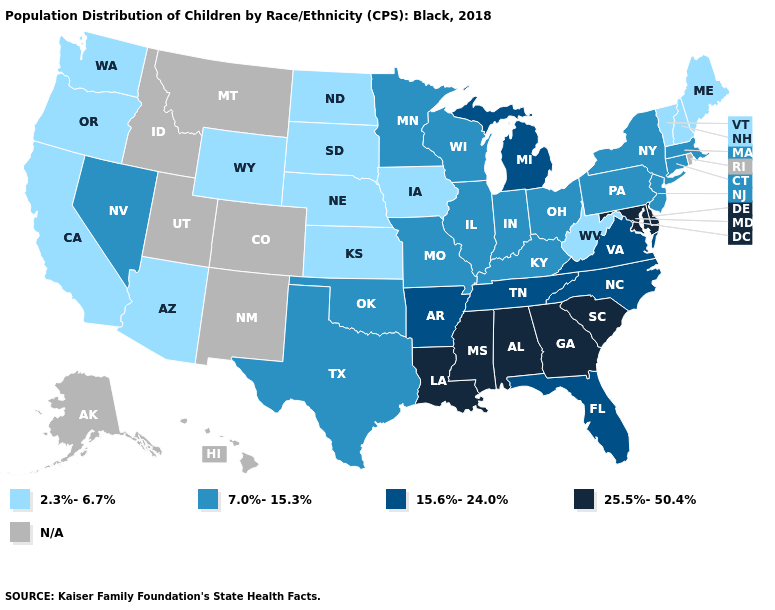Name the states that have a value in the range 25.5%-50.4%?
Concise answer only. Alabama, Delaware, Georgia, Louisiana, Maryland, Mississippi, South Carolina. What is the value of Ohio?
Write a very short answer. 7.0%-15.3%. How many symbols are there in the legend?
Short answer required. 5. Name the states that have a value in the range 7.0%-15.3%?
Keep it brief. Connecticut, Illinois, Indiana, Kentucky, Massachusetts, Minnesota, Missouri, Nevada, New Jersey, New York, Ohio, Oklahoma, Pennsylvania, Texas, Wisconsin. What is the lowest value in the West?
Keep it brief. 2.3%-6.7%. Does Delaware have the lowest value in the South?
Concise answer only. No. Among the states that border New York , which have the highest value?
Give a very brief answer. Connecticut, Massachusetts, New Jersey, Pennsylvania. Which states have the highest value in the USA?
Answer briefly. Alabama, Delaware, Georgia, Louisiana, Maryland, Mississippi, South Carolina. Does Tennessee have the highest value in the USA?
Be succinct. No. What is the value of Georgia?
Give a very brief answer. 25.5%-50.4%. Name the states that have a value in the range N/A?
Quick response, please. Alaska, Colorado, Hawaii, Idaho, Montana, New Mexico, Rhode Island, Utah. Does the map have missing data?
Write a very short answer. Yes. What is the lowest value in the USA?
Write a very short answer. 2.3%-6.7%. 